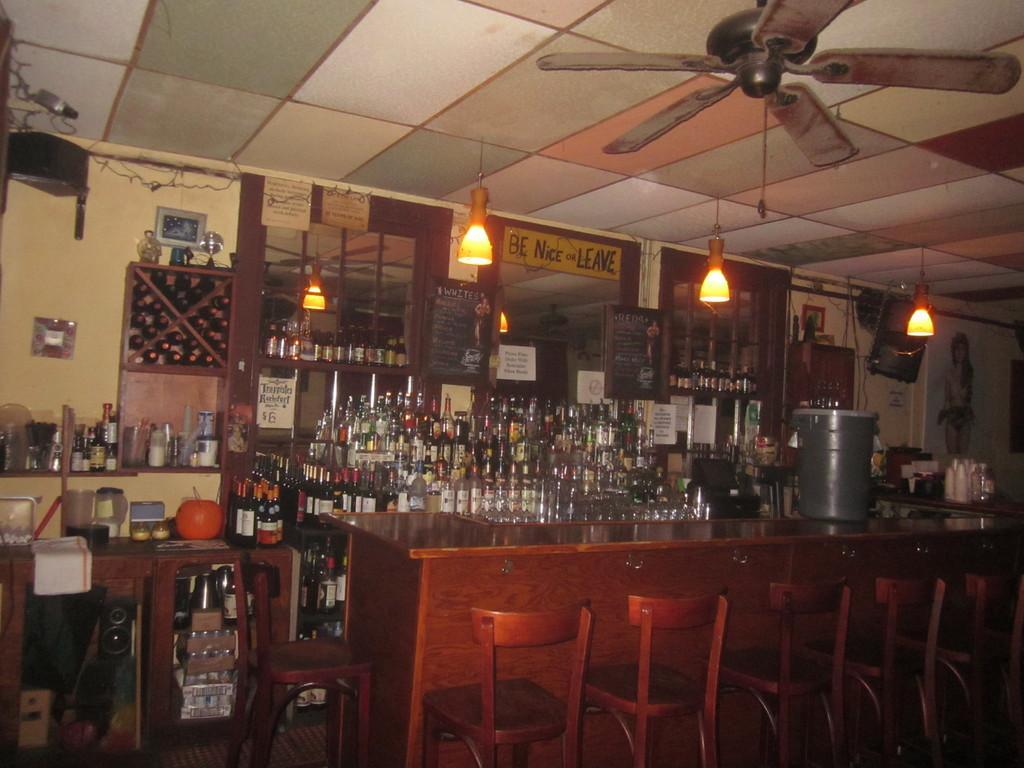Please provide a concise description of this image. This picture shows a bunch of bottles on the table and we see few lights on the roof and a ceiling fan and two see a water tin and few chairs and a table and we see photo frame on the wall 